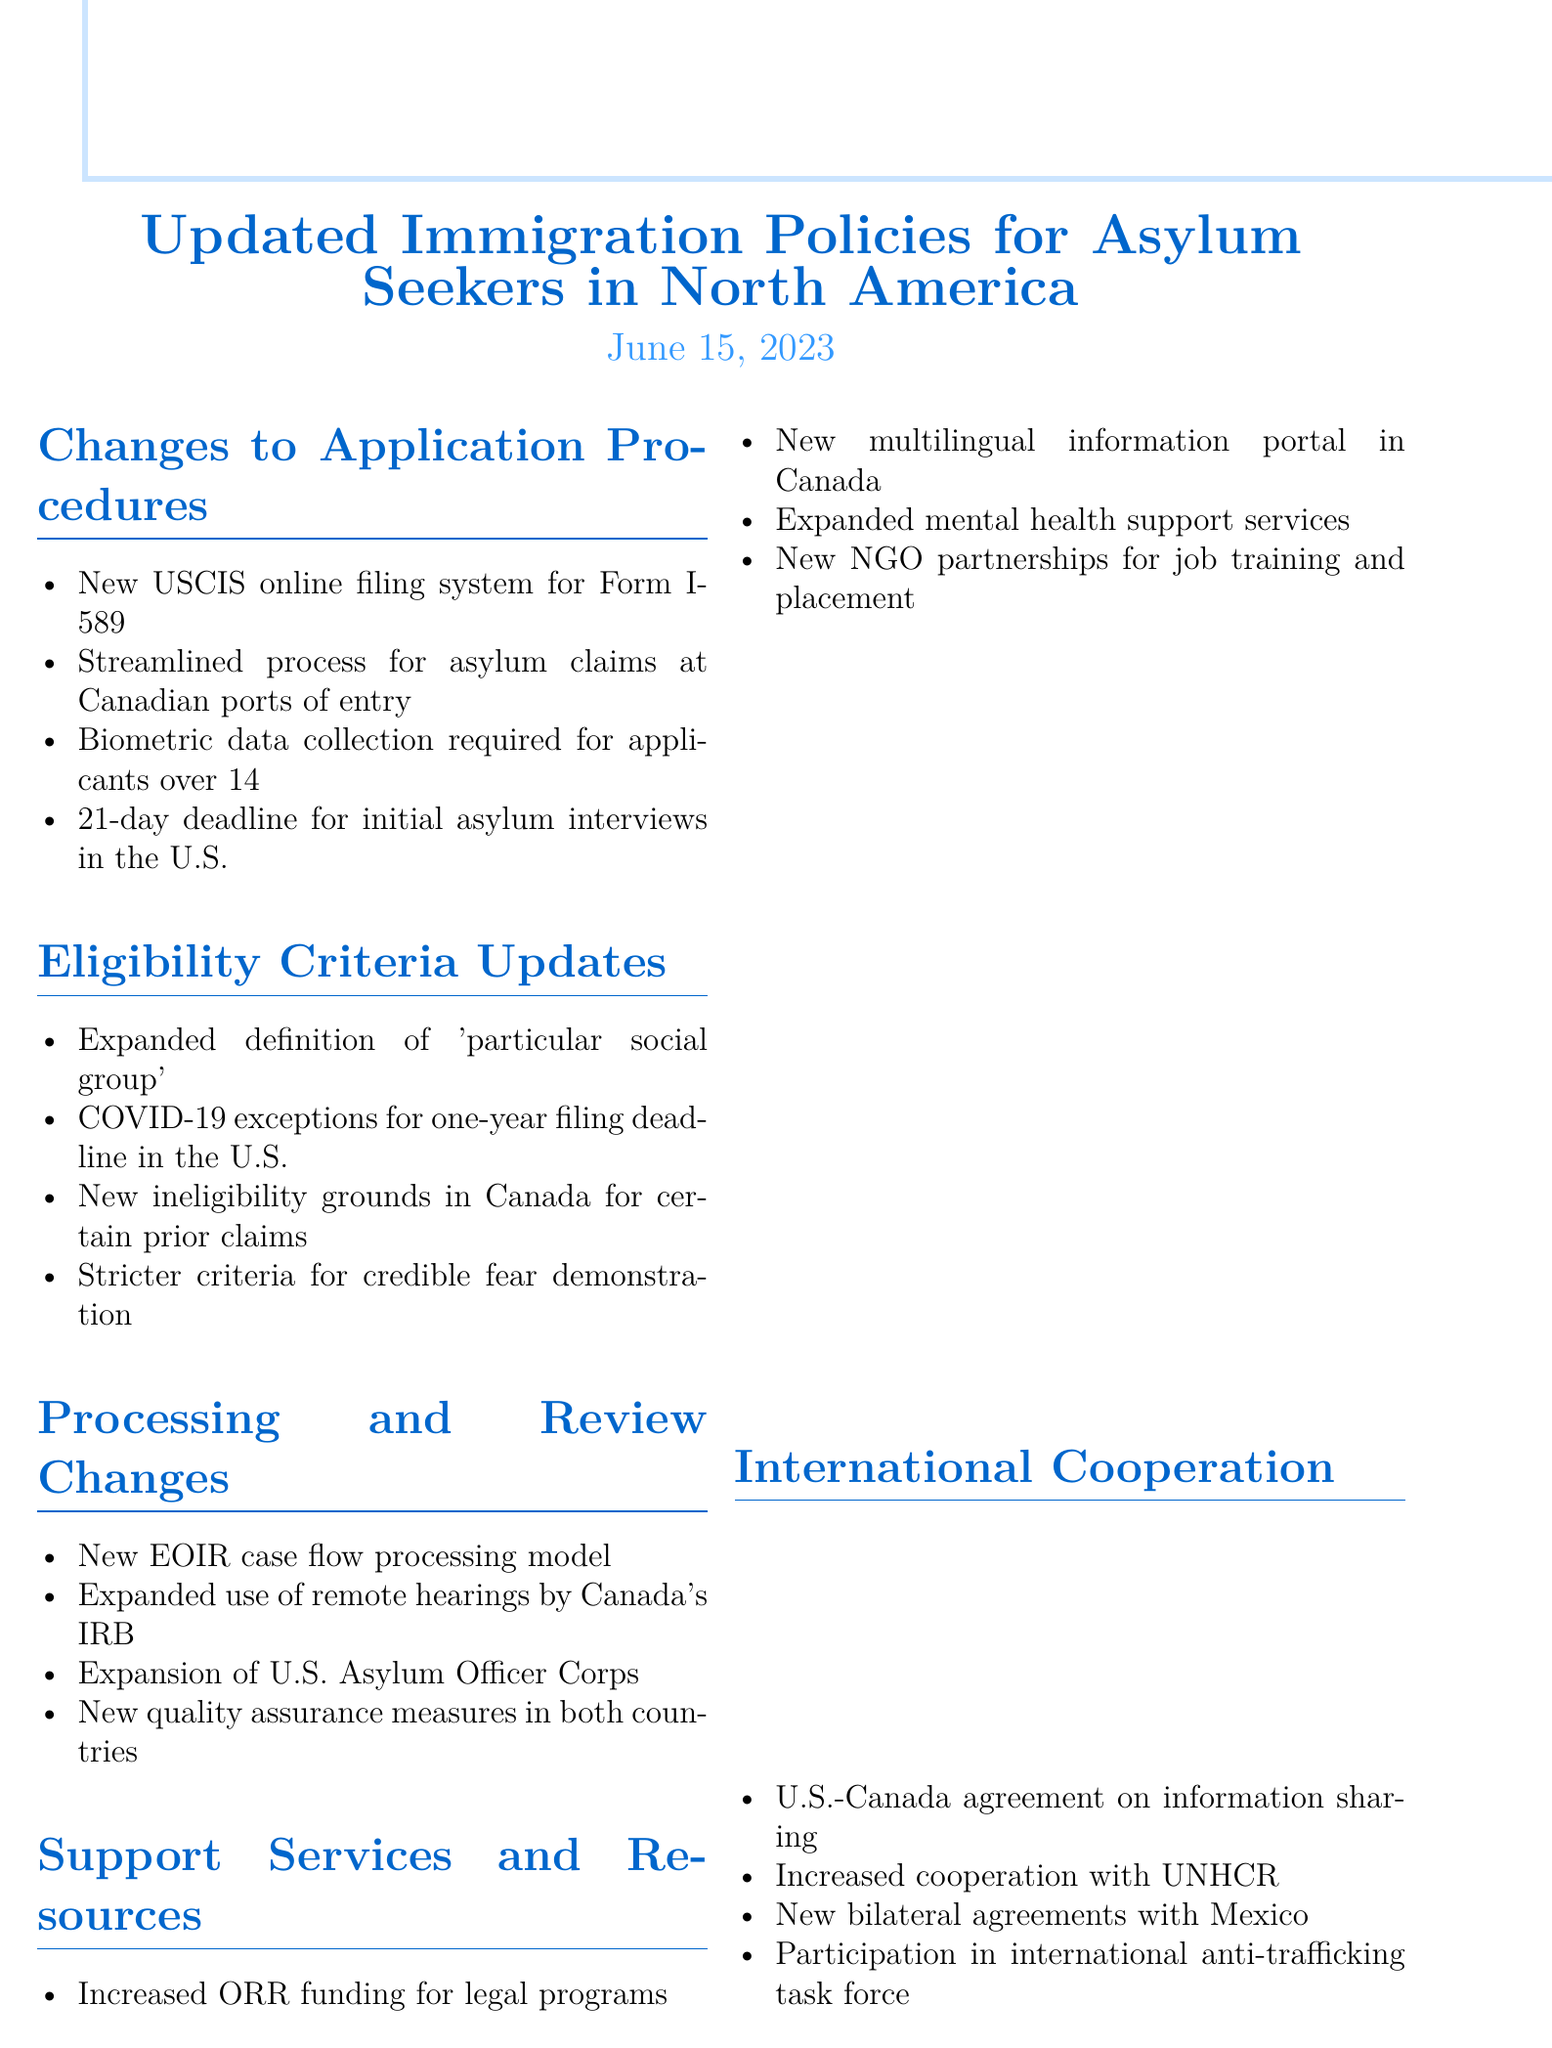What is the title of the memo? The title of the memo is the main heading that describes its subject.
Answer: Updated Immigration Policies for Asylum Seekers in North America When was the memo published? The publication date is indicated at the top of the memo.
Answer: June 15, 2023 What new procedure has USCIS implemented for Form I-589? This question asks for a specific procedural change mentioned in the document.
Answer: New online filing system Which age group is now required to provide biometric data? This question inquires about specific details regarding the age requirement for biometric data collection.
Answer: Over the age of 14 What is the 21-day deadline related to? The 21-day deadline pertains to a specific event mentioned in the application procedures.
Answer: Initial asylum interviews What grounds for ineligibility have been introduced in Canada? This question seeks to understand the specific change in eligibility for asylum seekers in Canada.
Answer: Previously made a claim in the United States, United Kingdom, Australia, or New Zealand Who is the Director of the Asylum Division at USCIS? This question requests a specific contact person mentioned in the memo.
Answer: Sarah Johnson What new resource has Canada launched for asylum seekers? This asks about a specific support initiative introduced in Canada.
Answer: Multilingual information portal What type of hearings has Canada's IRB expanded its use of? This question aims to identify a specific procedural change regarding hearings in Canada.
Answer: Remote hearings What international task force are North American countries participating in? This question refers to a specific collaborative effort mentioned in the memo.
Answer: International anti-trafficking task force 